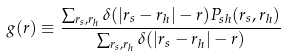Convert formula to latex. <formula><loc_0><loc_0><loc_500><loc_500>g ( r ) \equiv \frac { \sum _ { r _ { s } , r _ { h } } \delta ( | { r } _ { s } - { r } _ { h } | - r ) P _ { s h } ( { r } _ { s } , { r } _ { h } ) } { \sum _ { r _ { s } , r _ { h } } \delta ( | { r } _ { s } - { r } _ { h } | - r ) }</formula> 